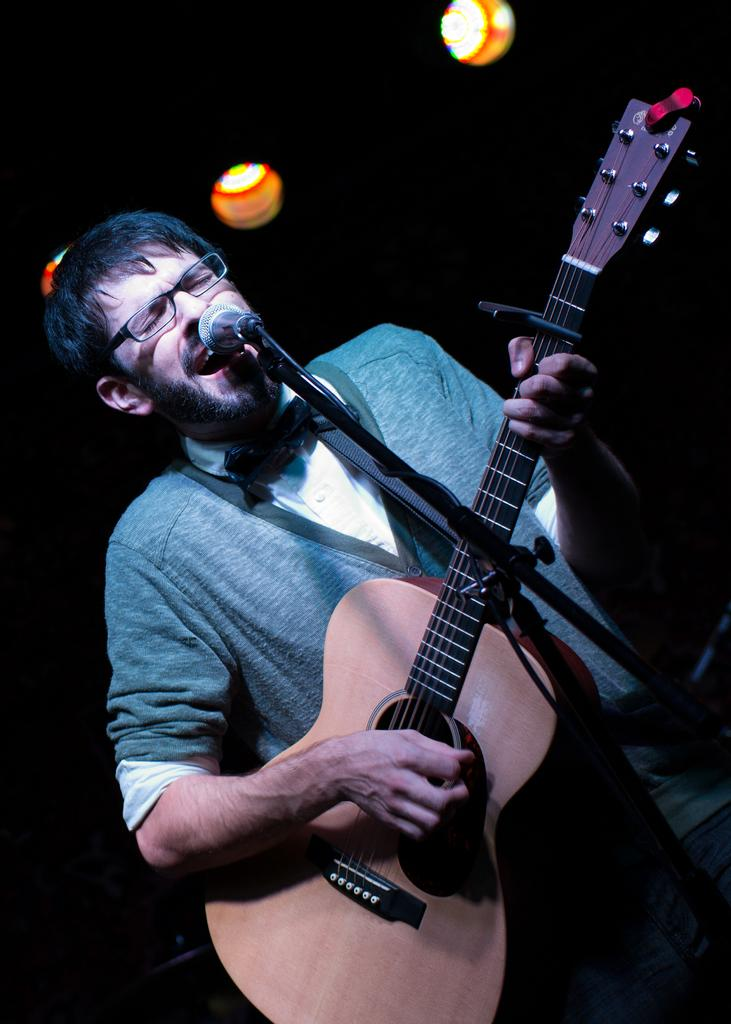What is the man in the image doing? The man is playing the guitar. What is the man wearing that helps him see better? The man is wearing glasses (specs). What instrument is the man holding? The man is holding a guitar. What is in front of the man that he might use for singing? There is a microphone (mic) in front of the man. What is supporting the microphone in front of the man? There is a microphone stand in front of the man. What can be seen in the background of the image? There are lights visible in the background of the image. What type of locket is the man wearing around his neck in the image? There is no locket visible around the man's neck in the image. What is the size of the guitar in the image? The size of the guitar cannot be determined from the image alone, as there is no reference for scale. 